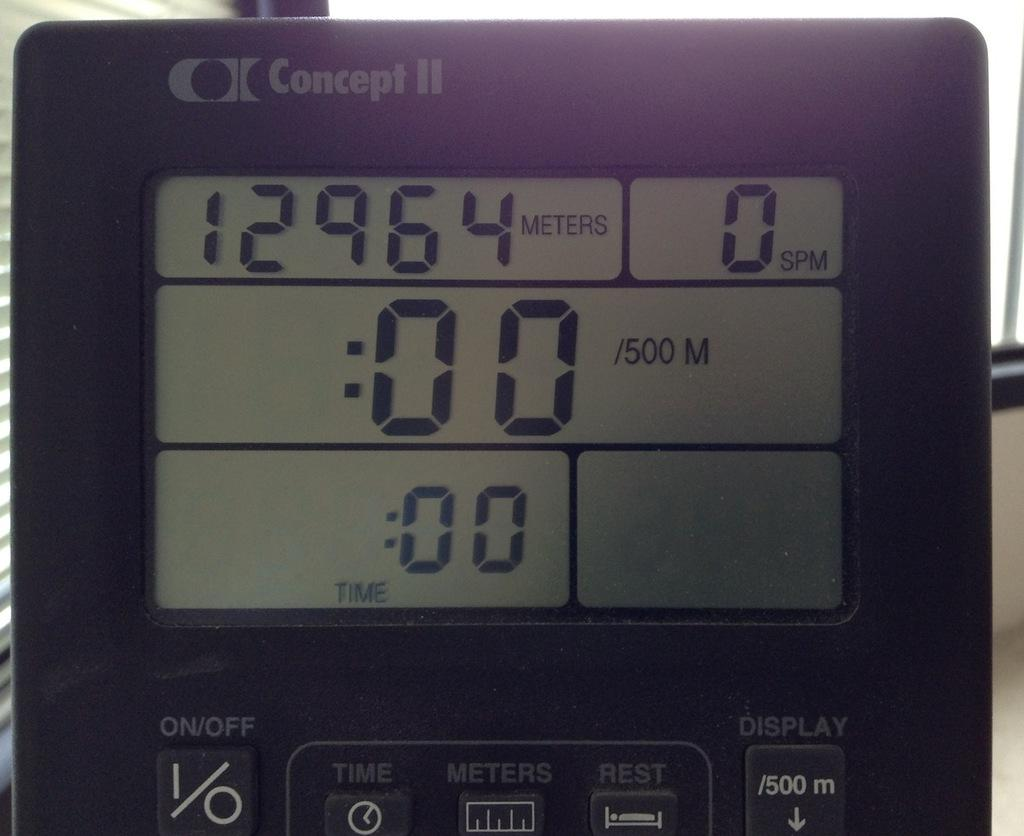<image>
Write a terse but informative summary of the picture. A small black step counter timer by Concept H. 